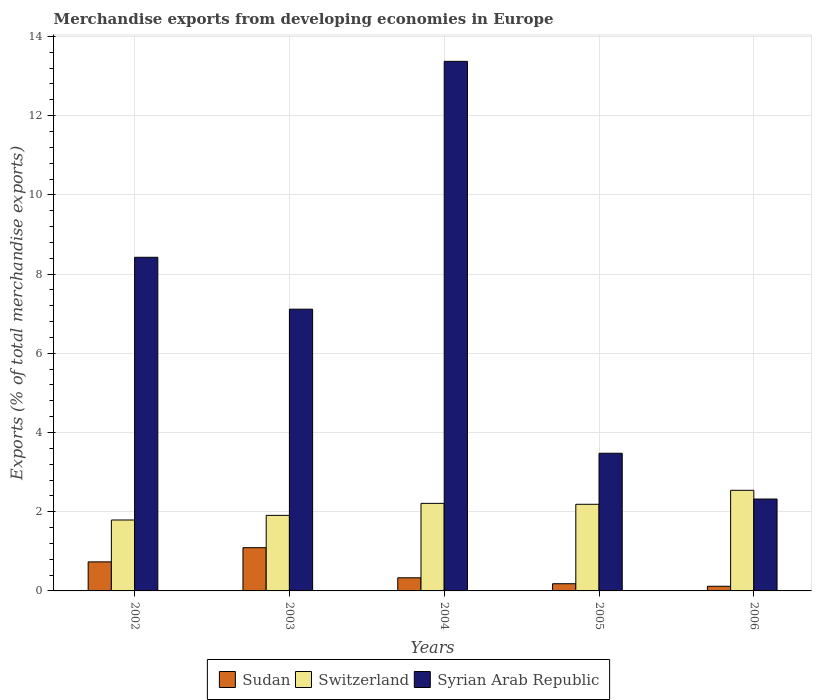Are the number of bars on each tick of the X-axis equal?
Offer a very short reply. Yes. How many bars are there on the 4th tick from the left?
Make the answer very short. 3. What is the percentage of total merchandise exports in Switzerland in 2004?
Provide a short and direct response. 2.21. Across all years, what is the maximum percentage of total merchandise exports in Syrian Arab Republic?
Keep it short and to the point. 13.37. Across all years, what is the minimum percentage of total merchandise exports in Switzerland?
Your answer should be compact. 1.79. In which year was the percentage of total merchandise exports in Switzerland maximum?
Provide a short and direct response. 2006. In which year was the percentage of total merchandise exports in Syrian Arab Republic minimum?
Keep it short and to the point. 2006. What is the total percentage of total merchandise exports in Syrian Arab Republic in the graph?
Give a very brief answer. 34.7. What is the difference between the percentage of total merchandise exports in Sudan in 2002 and that in 2005?
Offer a very short reply. 0.55. What is the difference between the percentage of total merchandise exports in Sudan in 2003 and the percentage of total merchandise exports in Switzerland in 2002?
Make the answer very short. -0.7. What is the average percentage of total merchandise exports in Sudan per year?
Provide a succinct answer. 0.49. In the year 2002, what is the difference between the percentage of total merchandise exports in Sudan and percentage of total merchandise exports in Switzerland?
Offer a terse response. -1.06. What is the ratio of the percentage of total merchandise exports in Switzerland in 2004 to that in 2005?
Provide a succinct answer. 1.01. Is the percentage of total merchandise exports in Sudan in 2004 less than that in 2005?
Offer a very short reply. No. Is the difference between the percentage of total merchandise exports in Sudan in 2003 and 2004 greater than the difference between the percentage of total merchandise exports in Switzerland in 2003 and 2004?
Ensure brevity in your answer.  Yes. What is the difference between the highest and the second highest percentage of total merchandise exports in Syrian Arab Republic?
Provide a succinct answer. 4.95. What is the difference between the highest and the lowest percentage of total merchandise exports in Switzerland?
Provide a short and direct response. 0.75. In how many years, is the percentage of total merchandise exports in Sudan greater than the average percentage of total merchandise exports in Sudan taken over all years?
Keep it short and to the point. 2. Is the sum of the percentage of total merchandise exports in Switzerland in 2002 and 2005 greater than the maximum percentage of total merchandise exports in Syrian Arab Republic across all years?
Offer a terse response. No. What does the 3rd bar from the left in 2002 represents?
Ensure brevity in your answer.  Syrian Arab Republic. What does the 3rd bar from the right in 2006 represents?
Keep it short and to the point. Sudan. How many bars are there?
Your answer should be compact. 15. Does the graph contain any zero values?
Your answer should be very brief. No. Where does the legend appear in the graph?
Your answer should be very brief. Bottom center. What is the title of the graph?
Ensure brevity in your answer.  Merchandise exports from developing economies in Europe. Does "Low & middle income" appear as one of the legend labels in the graph?
Provide a succinct answer. No. What is the label or title of the Y-axis?
Make the answer very short. Exports (% of total merchandise exports). What is the Exports (% of total merchandise exports) of Sudan in 2002?
Provide a short and direct response. 0.73. What is the Exports (% of total merchandise exports) of Switzerland in 2002?
Keep it short and to the point. 1.79. What is the Exports (% of total merchandise exports) in Syrian Arab Republic in 2002?
Your answer should be very brief. 8.42. What is the Exports (% of total merchandise exports) in Sudan in 2003?
Provide a short and direct response. 1.09. What is the Exports (% of total merchandise exports) of Switzerland in 2003?
Make the answer very short. 1.91. What is the Exports (% of total merchandise exports) in Syrian Arab Republic in 2003?
Offer a very short reply. 7.11. What is the Exports (% of total merchandise exports) in Sudan in 2004?
Make the answer very short. 0.33. What is the Exports (% of total merchandise exports) in Switzerland in 2004?
Provide a short and direct response. 2.21. What is the Exports (% of total merchandise exports) of Syrian Arab Republic in 2004?
Provide a succinct answer. 13.37. What is the Exports (% of total merchandise exports) of Sudan in 2005?
Offer a very short reply. 0.18. What is the Exports (% of total merchandise exports) in Switzerland in 2005?
Offer a very short reply. 2.19. What is the Exports (% of total merchandise exports) of Syrian Arab Republic in 2005?
Your response must be concise. 3.48. What is the Exports (% of total merchandise exports) of Sudan in 2006?
Offer a terse response. 0.12. What is the Exports (% of total merchandise exports) in Switzerland in 2006?
Make the answer very short. 2.54. What is the Exports (% of total merchandise exports) in Syrian Arab Republic in 2006?
Keep it short and to the point. 2.32. Across all years, what is the maximum Exports (% of total merchandise exports) of Sudan?
Make the answer very short. 1.09. Across all years, what is the maximum Exports (% of total merchandise exports) of Switzerland?
Offer a very short reply. 2.54. Across all years, what is the maximum Exports (% of total merchandise exports) in Syrian Arab Republic?
Offer a terse response. 13.37. Across all years, what is the minimum Exports (% of total merchandise exports) of Sudan?
Ensure brevity in your answer.  0.12. Across all years, what is the minimum Exports (% of total merchandise exports) in Switzerland?
Your response must be concise. 1.79. Across all years, what is the minimum Exports (% of total merchandise exports) in Syrian Arab Republic?
Provide a short and direct response. 2.32. What is the total Exports (% of total merchandise exports) of Sudan in the graph?
Your answer should be very brief. 2.46. What is the total Exports (% of total merchandise exports) of Switzerland in the graph?
Offer a very short reply. 10.64. What is the total Exports (% of total merchandise exports) in Syrian Arab Republic in the graph?
Your answer should be compact. 34.7. What is the difference between the Exports (% of total merchandise exports) in Sudan in 2002 and that in 2003?
Offer a very short reply. -0.36. What is the difference between the Exports (% of total merchandise exports) of Switzerland in 2002 and that in 2003?
Your answer should be very brief. -0.12. What is the difference between the Exports (% of total merchandise exports) in Syrian Arab Republic in 2002 and that in 2003?
Your answer should be very brief. 1.31. What is the difference between the Exports (% of total merchandise exports) in Sudan in 2002 and that in 2004?
Keep it short and to the point. 0.4. What is the difference between the Exports (% of total merchandise exports) of Switzerland in 2002 and that in 2004?
Provide a succinct answer. -0.42. What is the difference between the Exports (% of total merchandise exports) of Syrian Arab Republic in 2002 and that in 2004?
Your answer should be very brief. -4.95. What is the difference between the Exports (% of total merchandise exports) of Sudan in 2002 and that in 2005?
Your answer should be compact. 0.55. What is the difference between the Exports (% of total merchandise exports) of Switzerland in 2002 and that in 2005?
Provide a short and direct response. -0.4. What is the difference between the Exports (% of total merchandise exports) in Syrian Arab Republic in 2002 and that in 2005?
Ensure brevity in your answer.  4.95. What is the difference between the Exports (% of total merchandise exports) in Sudan in 2002 and that in 2006?
Make the answer very short. 0.62. What is the difference between the Exports (% of total merchandise exports) in Switzerland in 2002 and that in 2006?
Provide a short and direct response. -0.75. What is the difference between the Exports (% of total merchandise exports) of Syrian Arab Republic in 2002 and that in 2006?
Provide a short and direct response. 6.1. What is the difference between the Exports (% of total merchandise exports) in Sudan in 2003 and that in 2004?
Your answer should be very brief. 0.76. What is the difference between the Exports (% of total merchandise exports) of Switzerland in 2003 and that in 2004?
Offer a very short reply. -0.3. What is the difference between the Exports (% of total merchandise exports) of Syrian Arab Republic in 2003 and that in 2004?
Keep it short and to the point. -6.26. What is the difference between the Exports (% of total merchandise exports) in Sudan in 2003 and that in 2005?
Provide a short and direct response. 0.91. What is the difference between the Exports (% of total merchandise exports) in Switzerland in 2003 and that in 2005?
Keep it short and to the point. -0.28. What is the difference between the Exports (% of total merchandise exports) in Syrian Arab Republic in 2003 and that in 2005?
Offer a terse response. 3.64. What is the difference between the Exports (% of total merchandise exports) of Sudan in 2003 and that in 2006?
Your answer should be very brief. 0.97. What is the difference between the Exports (% of total merchandise exports) of Switzerland in 2003 and that in 2006?
Provide a short and direct response. -0.63. What is the difference between the Exports (% of total merchandise exports) of Syrian Arab Republic in 2003 and that in 2006?
Your response must be concise. 4.79. What is the difference between the Exports (% of total merchandise exports) of Sudan in 2004 and that in 2005?
Ensure brevity in your answer.  0.15. What is the difference between the Exports (% of total merchandise exports) of Switzerland in 2004 and that in 2005?
Make the answer very short. 0.02. What is the difference between the Exports (% of total merchandise exports) in Syrian Arab Republic in 2004 and that in 2005?
Make the answer very short. 9.89. What is the difference between the Exports (% of total merchandise exports) in Sudan in 2004 and that in 2006?
Give a very brief answer. 0.21. What is the difference between the Exports (% of total merchandise exports) in Switzerland in 2004 and that in 2006?
Provide a succinct answer. -0.33. What is the difference between the Exports (% of total merchandise exports) of Syrian Arab Republic in 2004 and that in 2006?
Keep it short and to the point. 11.05. What is the difference between the Exports (% of total merchandise exports) of Sudan in 2005 and that in 2006?
Your response must be concise. 0.06. What is the difference between the Exports (% of total merchandise exports) in Switzerland in 2005 and that in 2006?
Your response must be concise. -0.35. What is the difference between the Exports (% of total merchandise exports) of Syrian Arab Republic in 2005 and that in 2006?
Your response must be concise. 1.16. What is the difference between the Exports (% of total merchandise exports) in Sudan in 2002 and the Exports (% of total merchandise exports) in Switzerland in 2003?
Provide a succinct answer. -1.17. What is the difference between the Exports (% of total merchandise exports) in Sudan in 2002 and the Exports (% of total merchandise exports) in Syrian Arab Republic in 2003?
Ensure brevity in your answer.  -6.38. What is the difference between the Exports (% of total merchandise exports) in Switzerland in 2002 and the Exports (% of total merchandise exports) in Syrian Arab Republic in 2003?
Your response must be concise. -5.32. What is the difference between the Exports (% of total merchandise exports) in Sudan in 2002 and the Exports (% of total merchandise exports) in Switzerland in 2004?
Your answer should be compact. -1.48. What is the difference between the Exports (% of total merchandise exports) in Sudan in 2002 and the Exports (% of total merchandise exports) in Syrian Arab Republic in 2004?
Make the answer very short. -12.64. What is the difference between the Exports (% of total merchandise exports) of Switzerland in 2002 and the Exports (% of total merchandise exports) of Syrian Arab Republic in 2004?
Keep it short and to the point. -11.58. What is the difference between the Exports (% of total merchandise exports) in Sudan in 2002 and the Exports (% of total merchandise exports) in Switzerland in 2005?
Provide a short and direct response. -1.45. What is the difference between the Exports (% of total merchandise exports) in Sudan in 2002 and the Exports (% of total merchandise exports) in Syrian Arab Republic in 2005?
Your answer should be very brief. -2.74. What is the difference between the Exports (% of total merchandise exports) of Switzerland in 2002 and the Exports (% of total merchandise exports) of Syrian Arab Republic in 2005?
Your answer should be very brief. -1.69. What is the difference between the Exports (% of total merchandise exports) of Sudan in 2002 and the Exports (% of total merchandise exports) of Switzerland in 2006?
Give a very brief answer. -1.81. What is the difference between the Exports (% of total merchandise exports) of Sudan in 2002 and the Exports (% of total merchandise exports) of Syrian Arab Republic in 2006?
Your answer should be very brief. -1.59. What is the difference between the Exports (% of total merchandise exports) in Switzerland in 2002 and the Exports (% of total merchandise exports) in Syrian Arab Republic in 2006?
Keep it short and to the point. -0.53. What is the difference between the Exports (% of total merchandise exports) of Sudan in 2003 and the Exports (% of total merchandise exports) of Switzerland in 2004?
Your response must be concise. -1.12. What is the difference between the Exports (% of total merchandise exports) of Sudan in 2003 and the Exports (% of total merchandise exports) of Syrian Arab Republic in 2004?
Make the answer very short. -12.28. What is the difference between the Exports (% of total merchandise exports) of Switzerland in 2003 and the Exports (% of total merchandise exports) of Syrian Arab Republic in 2004?
Provide a succinct answer. -11.46. What is the difference between the Exports (% of total merchandise exports) of Sudan in 2003 and the Exports (% of total merchandise exports) of Switzerland in 2005?
Provide a succinct answer. -1.1. What is the difference between the Exports (% of total merchandise exports) in Sudan in 2003 and the Exports (% of total merchandise exports) in Syrian Arab Republic in 2005?
Make the answer very short. -2.38. What is the difference between the Exports (% of total merchandise exports) of Switzerland in 2003 and the Exports (% of total merchandise exports) of Syrian Arab Republic in 2005?
Give a very brief answer. -1.57. What is the difference between the Exports (% of total merchandise exports) of Sudan in 2003 and the Exports (% of total merchandise exports) of Switzerland in 2006?
Provide a short and direct response. -1.45. What is the difference between the Exports (% of total merchandise exports) in Sudan in 2003 and the Exports (% of total merchandise exports) in Syrian Arab Republic in 2006?
Offer a terse response. -1.23. What is the difference between the Exports (% of total merchandise exports) in Switzerland in 2003 and the Exports (% of total merchandise exports) in Syrian Arab Republic in 2006?
Your answer should be compact. -0.41. What is the difference between the Exports (% of total merchandise exports) in Sudan in 2004 and the Exports (% of total merchandise exports) in Switzerland in 2005?
Give a very brief answer. -1.86. What is the difference between the Exports (% of total merchandise exports) of Sudan in 2004 and the Exports (% of total merchandise exports) of Syrian Arab Republic in 2005?
Offer a very short reply. -3.14. What is the difference between the Exports (% of total merchandise exports) of Switzerland in 2004 and the Exports (% of total merchandise exports) of Syrian Arab Republic in 2005?
Provide a succinct answer. -1.27. What is the difference between the Exports (% of total merchandise exports) of Sudan in 2004 and the Exports (% of total merchandise exports) of Switzerland in 2006?
Keep it short and to the point. -2.21. What is the difference between the Exports (% of total merchandise exports) of Sudan in 2004 and the Exports (% of total merchandise exports) of Syrian Arab Republic in 2006?
Offer a terse response. -1.99. What is the difference between the Exports (% of total merchandise exports) of Switzerland in 2004 and the Exports (% of total merchandise exports) of Syrian Arab Republic in 2006?
Offer a terse response. -0.11. What is the difference between the Exports (% of total merchandise exports) in Sudan in 2005 and the Exports (% of total merchandise exports) in Switzerland in 2006?
Provide a succinct answer. -2.36. What is the difference between the Exports (% of total merchandise exports) of Sudan in 2005 and the Exports (% of total merchandise exports) of Syrian Arab Republic in 2006?
Offer a very short reply. -2.14. What is the difference between the Exports (% of total merchandise exports) of Switzerland in 2005 and the Exports (% of total merchandise exports) of Syrian Arab Republic in 2006?
Your response must be concise. -0.13. What is the average Exports (% of total merchandise exports) in Sudan per year?
Keep it short and to the point. 0.49. What is the average Exports (% of total merchandise exports) in Switzerland per year?
Make the answer very short. 2.13. What is the average Exports (% of total merchandise exports) in Syrian Arab Republic per year?
Keep it short and to the point. 6.94. In the year 2002, what is the difference between the Exports (% of total merchandise exports) in Sudan and Exports (% of total merchandise exports) in Switzerland?
Ensure brevity in your answer.  -1.06. In the year 2002, what is the difference between the Exports (% of total merchandise exports) in Sudan and Exports (% of total merchandise exports) in Syrian Arab Republic?
Offer a terse response. -7.69. In the year 2002, what is the difference between the Exports (% of total merchandise exports) in Switzerland and Exports (% of total merchandise exports) in Syrian Arab Republic?
Your answer should be compact. -6.63. In the year 2003, what is the difference between the Exports (% of total merchandise exports) of Sudan and Exports (% of total merchandise exports) of Switzerland?
Provide a short and direct response. -0.82. In the year 2003, what is the difference between the Exports (% of total merchandise exports) in Sudan and Exports (% of total merchandise exports) in Syrian Arab Republic?
Provide a succinct answer. -6.02. In the year 2003, what is the difference between the Exports (% of total merchandise exports) in Switzerland and Exports (% of total merchandise exports) in Syrian Arab Republic?
Your response must be concise. -5.21. In the year 2004, what is the difference between the Exports (% of total merchandise exports) in Sudan and Exports (% of total merchandise exports) in Switzerland?
Give a very brief answer. -1.88. In the year 2004, what is the difference between the Exports (% of total merchandise exports) in Sudan and Exports (% of total merchandise exports) in Syrian Arab Republic?
Offer a very short reply. -13.04. In the year 2004, what is the difference between the Exports (% of total merchandise exports) of Switzerland and Exports (% of total merchandise exports) of Syrian Arab Republic?
Provide a short and direct response. -11.16. In the year 2005, what is the difference between the Exports (% of total merchandise exports) in Sudan and Exports (% of total merchandise exports) in Switzerland?
Your answer should be very brief. -2.01. In the year 2005, what is the difference between the Exports (% of total merchandise exports) in Sudan and Exports (% of total merchandise exports) in Syrian Arab Republic?
Ensure brevity in your answer.  -3.29. In the year 2005, what is the difference between the Exports (% of total merchandise exports) of Switzerland and Exports (% of total merchandise exports) of Syrian Arab Republic?
Provide a succinct answer. -1.29. In the year 2006, what is the difference between the Exports (% of total merchandise exports) of Sudan and Exports (% of total merchandise exports) of Switzerland?
Your response must be concise. -2.42. In the year 2006, what is the difference between the Exports (% of total merchandise exports) in Sudan and Exports (% of total merchandise exports) in Syrian Arab Republic?
Ensure brevity in your answer.  -2.2. In the year 2006, what is the difference between the Exports (% of total merchandise exports) in Switzerland and Exports (% of total merchandise exports) in Syrian Arab Republic?
Offer a terse response. 0.22. What is the ratio of the Exports (% of total merchandise exports) in Sudan in 2002 to that in 2003?
Provide a short and direct response. 0.67. What is the ratio of the Exports (% of total merchandise exports) of Switzerland in 2002 to that in 2003?
Keep it short and to the point. 0.94. What is the ratio of the Exports (% of total merchandise exports) of Syrian Arab Republic in 2002 to that in 2003?
Keep it short and to the point. 1.18. What is the ratio of the Exports (% of total merchandise exports) in Sudan in 2002 to that in 2004?
Keep it short and to the point. 2.21. What is the ratio of the Exports (% of total merchandise exports) in Switzerland in 2002 to that in 2004?
Keep it short and to the point. 0.81. What is the ratio of the Exports (% of total merchandise exports) of Syrian Arab Republic in 2002 to that in 2004?
Keep it short and to the point. 0.63. What is the ratio of the Exports (% of total merchandise exports) of Sudan in 2002 to that in 2005?
Your response must be concise. 4.04. What is the ratio of the Exports (% of total merchandise exports) in Switzerland in 2002 to that in 2005?
Your response must be concise. 0.82. What is the ratio of the Exports (% of total merchandise exports) of Syrian Arab Republic in 2002 to that in 2005?
Give a very brief answer. 2.42. What is the ratio of the Exports (% of total merchandise exports) of Sudan in 2002 to that in 2006?
Ensure brevity in your answer.  6.24. What is the ratio of the Exports (% of total merchandise exports) of Switzerland in 2002 to that in 2006?
Provide a short and direct response. 0.7. What is the ratio of the Exports (% of total merchandise exports) in Syrian Arab Republic in 2002 to that in 2006?
Offer a very short reply. 3.63. What is the ratio of the Exports (% of total merchandise exports) of Sudan in 2003 to that in 2004?
Your answer should be very brief. 3.29. What is the ratio of the Exports (% of total merchandise exports) of Switzerland in 2003 to that in 2004?
Your response must be concise. 0.86. What is the ratio of the Exports (% of total merchandise exports) in Syrian Arab Republic in 2003 to that in 2004?
Your response must be concise. 0.53. What is the ratio of the Exports (% of total merchandise exports) of Sudan in 2003 to that in 2005?
Provide a succinct answer. 6.01. What is the ratio of the Exports (% of total merchandise exports) in Switzerland in 2003 to that in 2005?
Your response must be concise. 0.87. What is the ratio of the Exports (% of total merchandise exports) of Syrian Arab Republic in 2003 to that in 2005?
Offer a very short reply. 2.05. What is the ratio of the Exports (% of total merchandise exports) of Sudan in 2003 to that in 2006?
Offer a terse response. 9.29. What is the ratio of the Exports (% of total merchandise exports) of Switzerland in 2003 to that in 2006?
Provide a succinct answer. 0.75. What is the ratio of the Exports (% of total merchandise exports) in Syrian Arab Republic in 2003 to that in 2006?
Ensure brevity in your answer.  3.07. What is the ratio of the Exports (% of total merchandise exports) in Sudan in 2004 to that in 2005?
Offer a terse response. 1.83. What is the ratio of the Exports (% of total merchandise exports) in Switzerland in 2004 to that in 2005?
Offer a very short reply. 1.01. What is the ratio of the Exports (% of total merchandise exports) of Syrian Arab Republic in 2004 to that in 2005?
Keep it short and to the point. 3.85. What is the ratio of the Exports (% of total merchandise exports) of Sudan in 2004 to that in 2006?
Provide a short and direct response. 2.82. What is the ratio of the Exports (% of total merchandise exports) in Switzerland in 2004 to that in 2006?
Ensure brevity in your answer.  0.87. What is the ratio of the Exports (% of total merchandise exports) of Syrian Arab Republic in 2004 to that in 2006?
Offer a terse response. 5.76. What is the ratio of the Exports (% of total merchandise exports) in Sudan in 2005 to that in 2006?
Give a very brief answer. 1.54. What is the ratio of the Exports (% of total merchandise exports) of Switzerland in 2005 to that in 2006?
Offer a terse response. 0.86. What is the ratio of the Exports (% of total merchandise exports) of Syrian Arab Republic in 2005 to that in 2006?
Provide a succinct answer. 1.5. What is the difference between the highest and the second highest Exports (% of total merchandise exports) of Sudan?
Ensure brevity in your answer.  0.36. What is the difference between the highest and the second highest Exports (% of total merchandise exports) in Switzerland?
Provide a short and direct response. 0.33. What is the difference between the highest and the second highest Exports (% of total merchandise exports) of Syrian Arab Republic?
Offer a very short reply. 4.95. What is the difference between the highest and the lowest Exports (% of total merchandise exports) in Sudan?
Make the answer very short. 0.97. What is the difference between the highest and the lowest Exports (% of total merchandise exports) of Switzerland?
Make the answer very short. 0.75. What is the difference between the highest and the lowest Exports (% of total merchandise exports) of Syrian Arab Republic?
Provide a succinct answer. 11.05. 